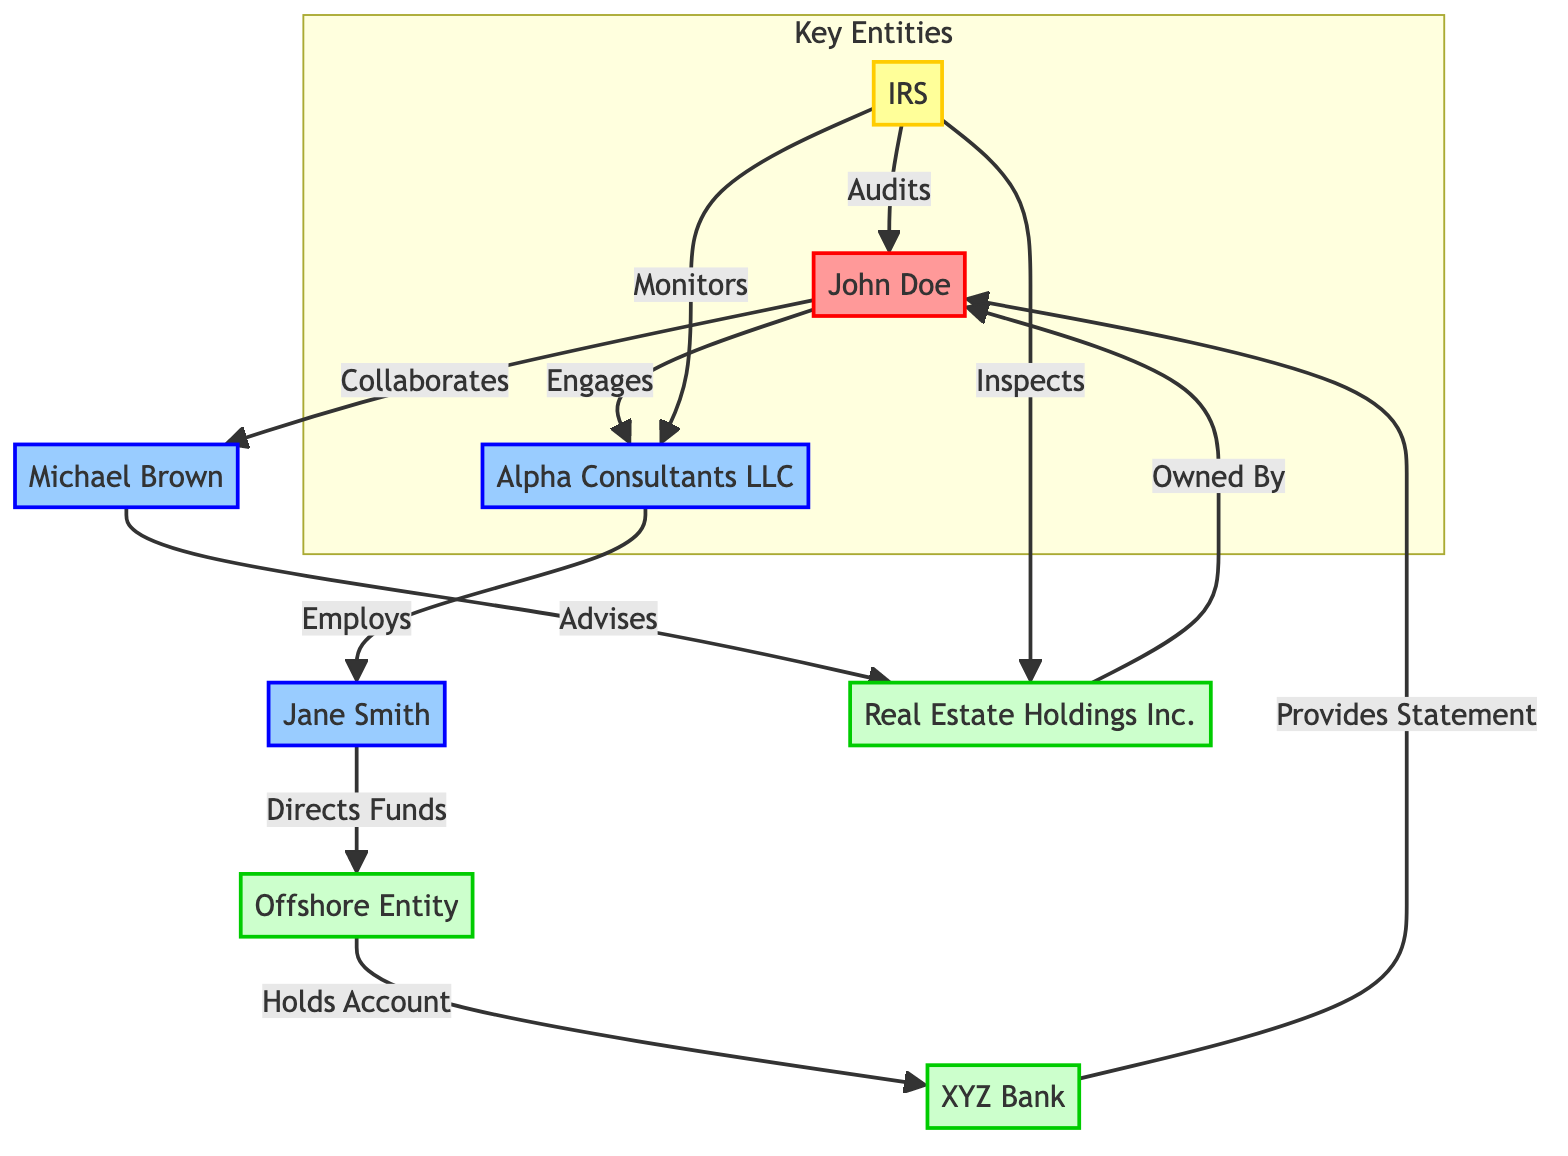What is the total number of nodes in the diagram? The diagram contains eight distinct entities: John Doe, Alpha Consultants LLC, Jane Smith, Offshore Entity, XYZ Bank, Michael Brown, Real Estate Holdings Inc., and the IRS. Therefore, the total number of nodes is 8.
Answer: 8 Who audits John Doe? The IRS is identified in the diagram as the entity that audits John Doe, indicating a regulatory oversight relationship.
Answer: IRS What type of entity is Michael Brown? Michael Brown is classified as an advisor in the diagram, as indicated by his role listed next to his name.
Answer: Advisor How many connections does John Doe have? John Doe has four outgoing connections: he engages with Alpha Consultants LLC, collaborates with Michael Brown, has funds directed to Offshore Entity, and is audited by the IRS. Thus, there are four connections.
Answer: 4 Which entity holds accounts for Offshore Entity? In the diagram, the XYZ Bank is shown to hold accounts for the Offshore Entity, indicating a financial relationship.
Answer: XYZ Bank What action does Jane Smith perform related to Offshore Entity? Jane Smith directs funds to the Offshore Entity, establishing her role in managing financial transactions within this network.
Answer: Directs Funds What is the relationship between Real Estate Holdings Inc. and John Doe? Real Estate Holdings Inc. is owned by John Doe, indicating a direct ownership relationship which is represented by an outgoing connection in the diagram.
Answer: Owned By Which two entities does the IRS monitor? The IRS monitors both Alpha Consultants LLC and Real Estate Holdings Inc., reflecting its regulatory function over these entities.
Answer: Alpha Consultants LLC and Real Estate Holdings Inc How many edges are present in the diagram? The diagram contains eleven directed edges representing different transactions or relationships among the nodes, including interactions between taxpayers, advisors, banks, and the IRS.
Answer: 11 